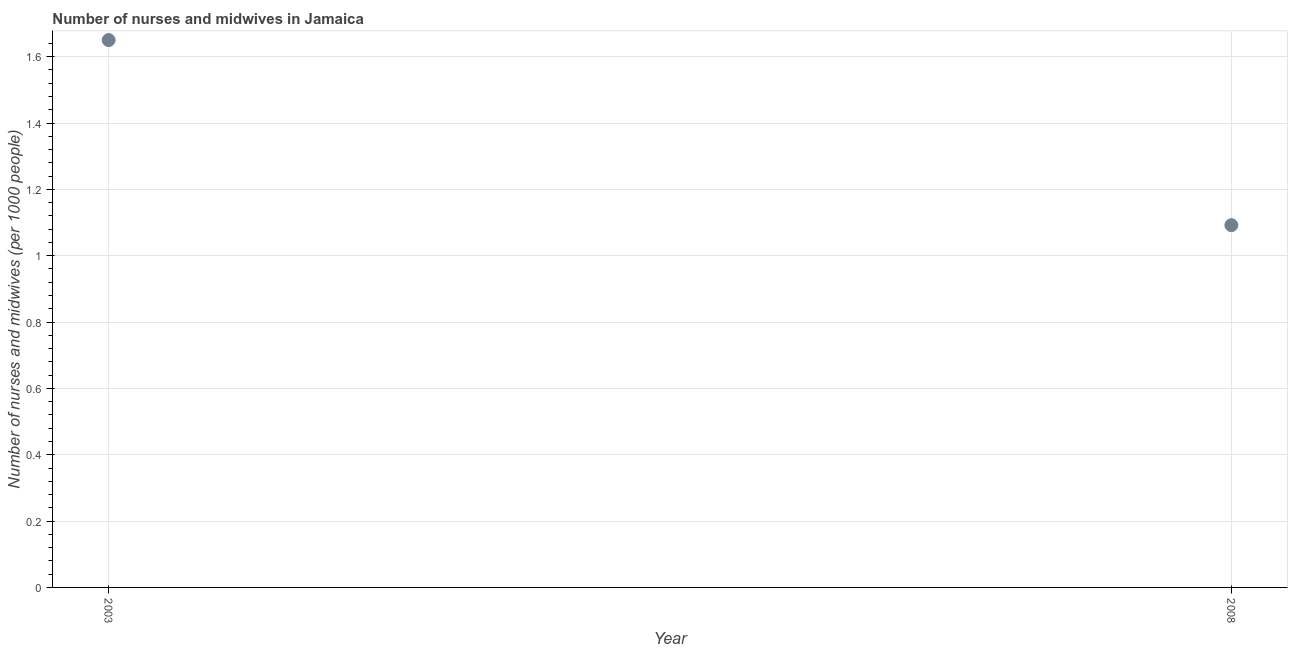What is the number of nurses and midwives in 2003?
Give a very brief answer. 1.65. Across all years, what is the maximum number of nurses and midwives?
Your answer should be compact. 1.65. Across all years, what is the minimum number of nurses and midwives?
Offer a very short reply. 1.09. In which year was the number of nurses and midwives maximum?
Offer a very short reply. 2003. What is the sum of the number of nurses and midwives?
Offer a very short reply. 2.74. What is the difference between the number of nurses and midwives in 2003 and 2008?
Make the answer very short. 0.56. What is the average number of nurses and midwives per year?
Offer a very short reply. 1.37. What is the median number of nurses and midwives?
Keep it short and to the point. 1.37. In how many years, is the number of nurses and midwives greater than 1 ?
Offer a very short reply. 2. Do a majority of the years between 2003 and 2008 (inclusive) have number of nurses and midwives greater than 0.44 ?
Provide a short and direct response. Yes. What is the ratio of the number of nurses and midwives in 2003 to that in 2008?
Keep it short and to the point. 1.51. In how many years, is the number of nurses and midwives greater than the average number of nurses and midwives taken over all years?
Your response must be concise. 1. Does the graph contain any zero values?
Your response must be concise. No. Does the graph contain grids?
Keep it short and to the point. Yes. What is the title of the graph?
Your response must be concise. Number of nurses and midwives in Jamaica. What is the label or title of the Y-axis?
Ensure brevity in your answer.  Number of nurses and midwives (per 1000 people). What is the Number of nurses and midwives (per 1000 people) in 2003?
Your response must be concise. 1.65. What is the Number of nurses and midwives (per 1000 people) in 2008?
Make the answer very short. 1.09. What is the difference between the Number of nurses and midwives (per 1000 people) in 2003 and 2008?
Provide a succinct answer. 0.56. What is the ratio of the Number of nurses and midwives (per 1000 people) in 2003 to that in 2008?
Your answer should be compact. 1.51. 